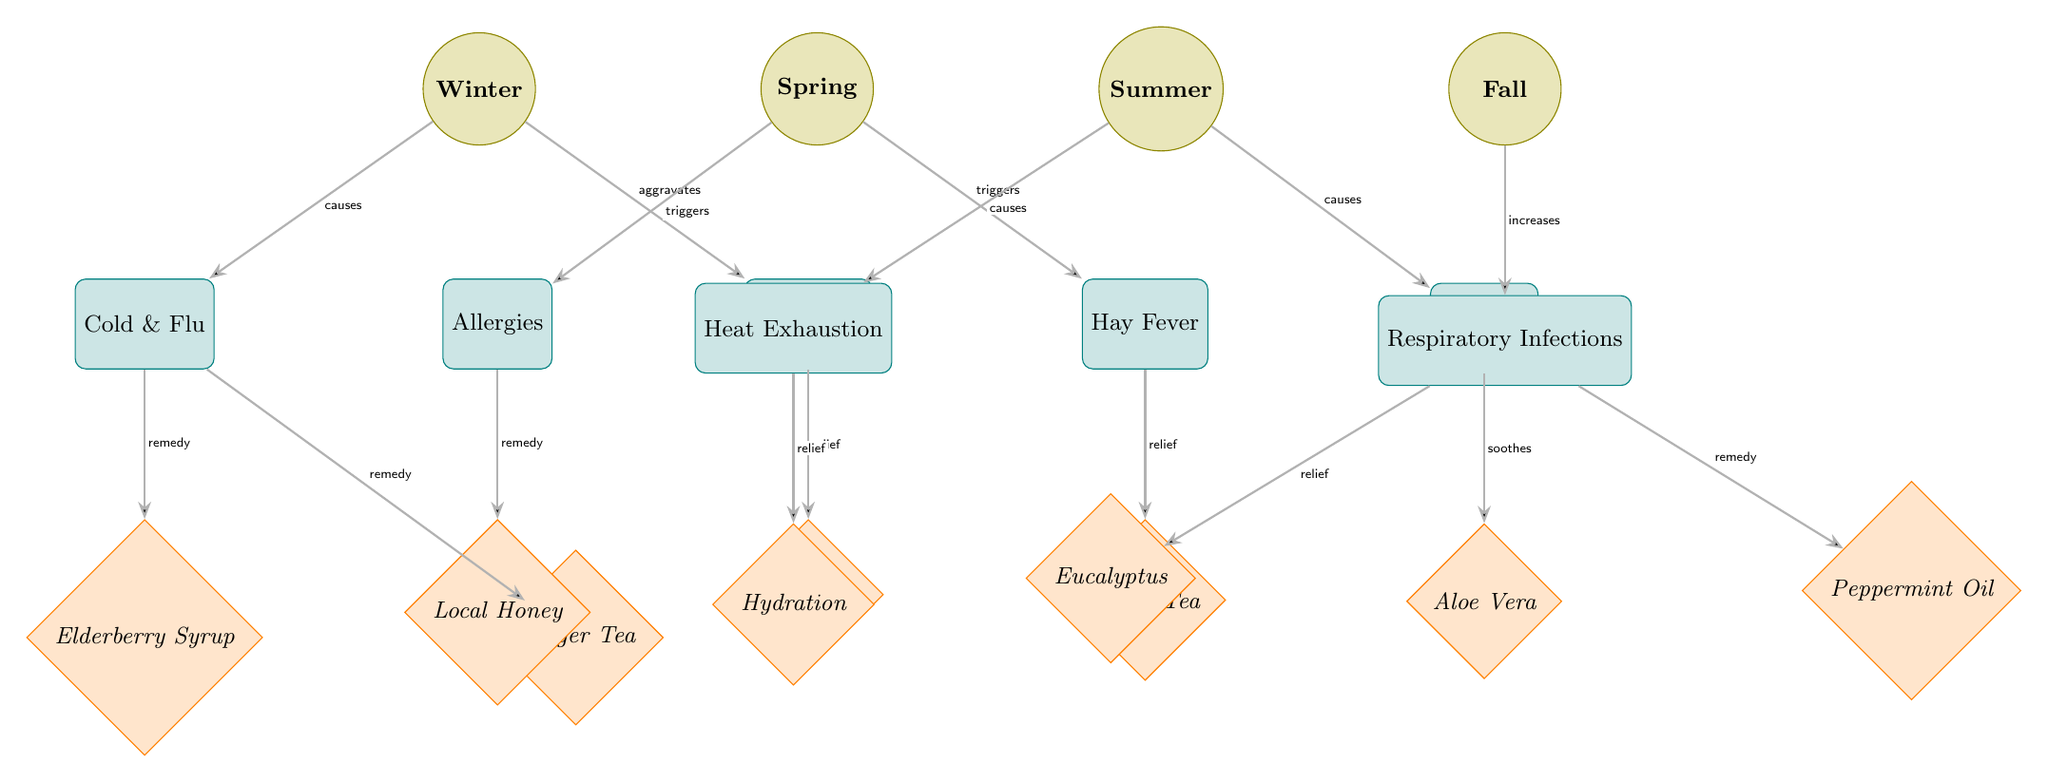What ailments are associated with winter? In the diagram, winter is connected to two ailments: Cold & Flu and Joint Pain. By tracing the connections from the winter node, we see these two specific ailments.
Answer: Cold & Flu, Joint Pain How many remedies are suggested for respiratory infections? The respiratory infections node connects to two remedies: Eucalyptus and Peppermint Oil. By counting the connections from respiratory infections, we find there are two remedies available.
Answer: 2 What remedy is suggested for allergies? Looking at the allergies node, the diagram shows a connection to Local Honey as the remedy. This gives us a direct answer regarding the suggested remedy for allergies.
Answer: Local Honey Which season triggers hay fever? By examining the diagram, hay fever is linked to the spring season. The connection indicates that spring triggers hay fever specifically.
Answer: Spring What is the relationship between heat exhaustion and summer? The diagram illustrates a direct cause-and-effect relationship, stating that summer causes heat exhaustion. This shows how the two elements interact.
Answer: causes Which remedy is used for joint pain relief? The joint pain node in the diagram leads to the remedy Turmeric, specifically noted for providing relief. Thus, we find that the remedy connected to joint pain is Turmeric.
Answer: Turmeric What season causes sunburn? By analyzing the diagram, it clearly states that summer causes sunburn. Hence, summer is the season responsible for this ailment.
Answer: Summer What are the two remedies associated with cold and flu? The cold & flu node has connections leading to two remedies: Elderberry Syrup and Ginger Tea. This reveals the specific remedies available for cold & flu treatment.
Answer: Elderberry Syrup, Ginger Tea Which remedies soothe sunburn? The sunburn node has a connection to Aloe Vera, which is specifically indicated as a soothing remedy for this ailment. Therefore, Aloe Vera is the remedy associated with sunburn relief.
Answer: Aloe Vera 